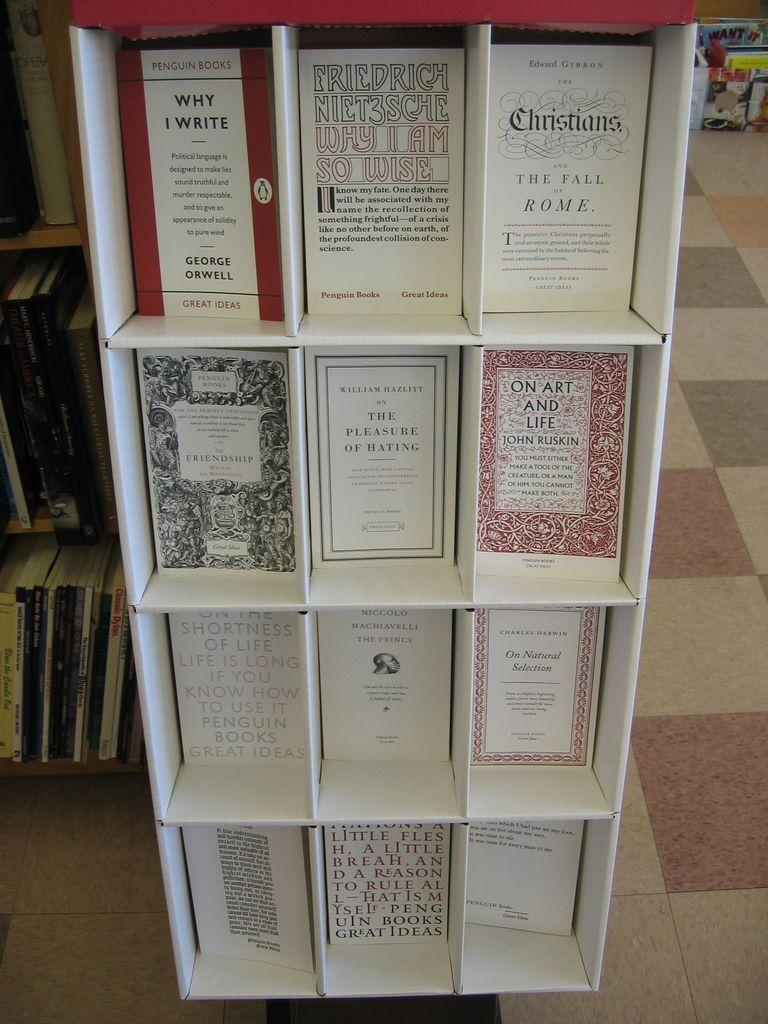<image>
Create a compact narrative representing the image presented. many books and one that has the word Christians on it 